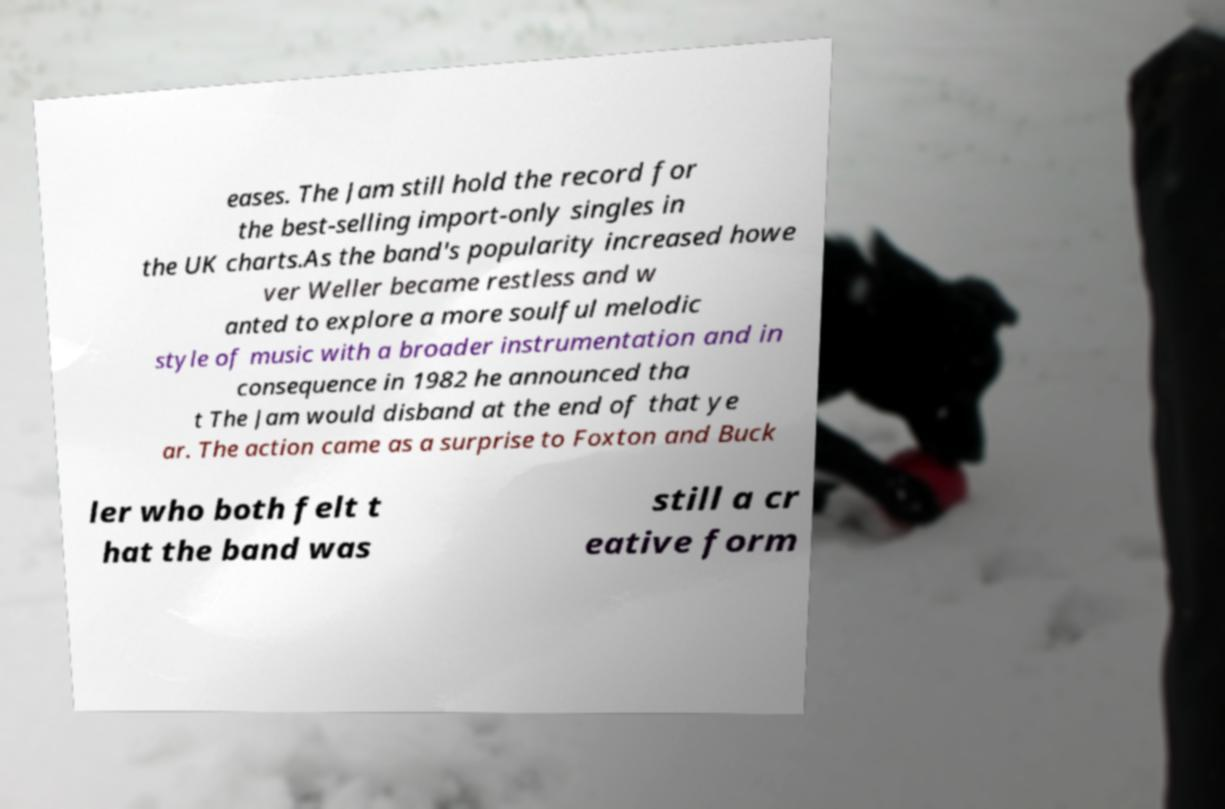What messages or text are displayed in this image? I need them in a readable, typed format. eases. The Jam still hold the record for the best-selling import-only singles in the UK charts.As the band's popularity increased howe ver Weller became restless and w anted to explore a more soulful melodic style of music with a broader instrumentation and in consequence in 1982 he announced tha t The Jam would disband at the end of that ye ar. The action came as a surprise to Foxton and Buck ler who both felt t hat the band was still a cr eative form 